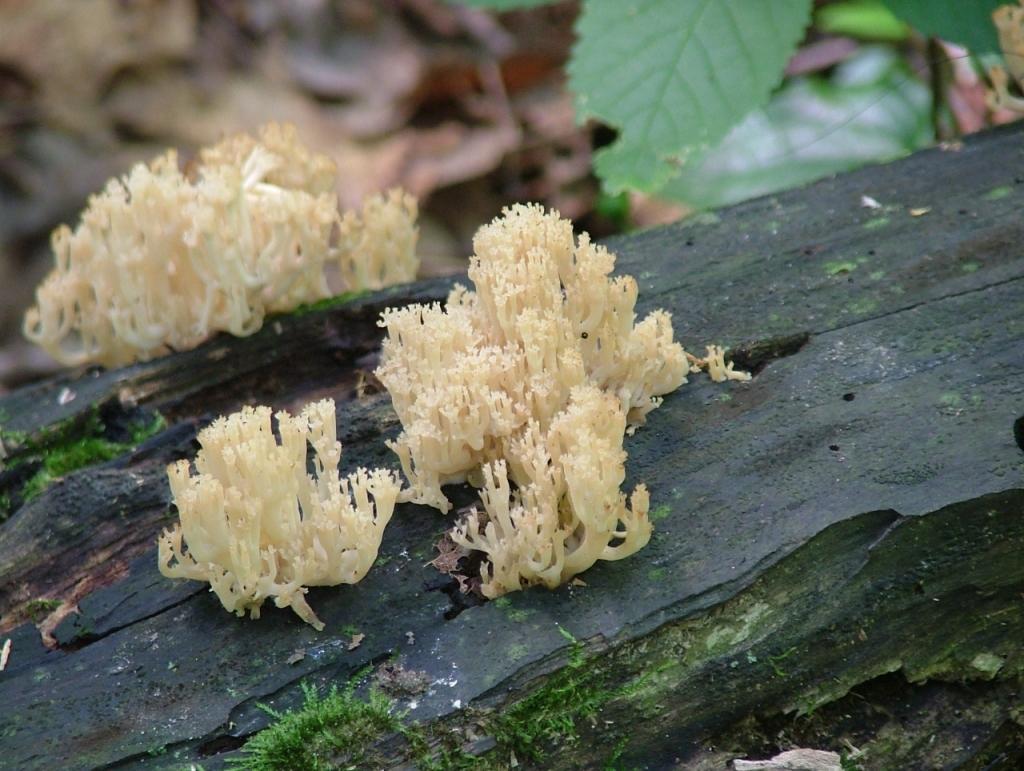Can you describe this image briefly? In this picture we can see fungus on the wooden bark, in the background we can find few plants. 